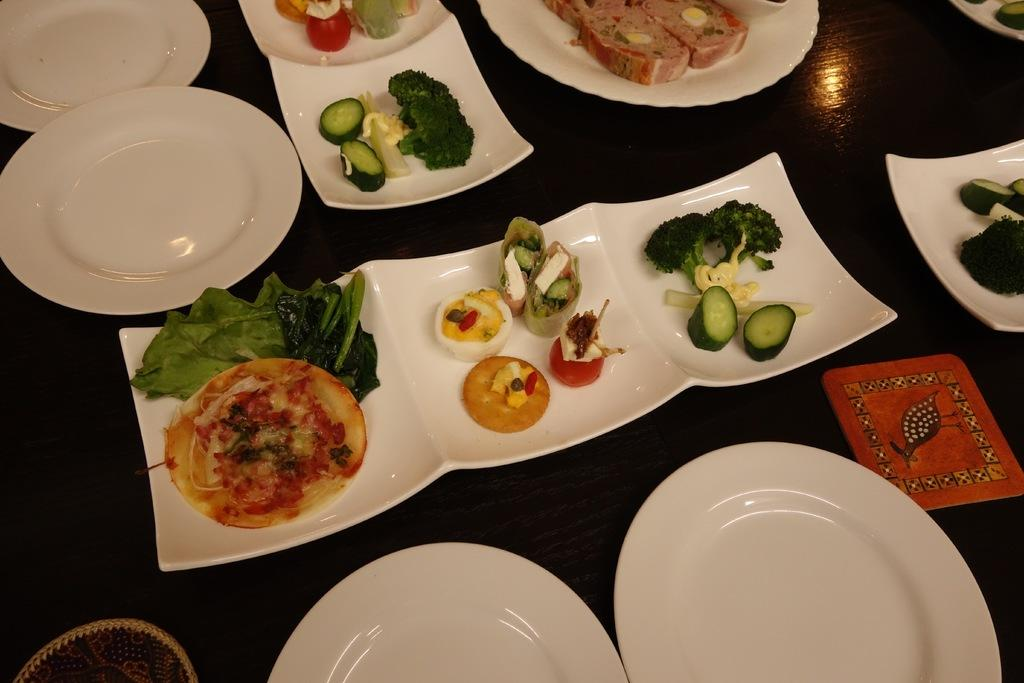What objects can be seen in the image? There are plates in the image. What is on the plates? There is food on the plates. Can you tell me how many kittens are sitting on the plates in the image? There are no kittens present in the image; it only features plates with food on them. What type of learning activity is taking place in the image? There is no learning activity depicted in the image; it only shows plates with food. 